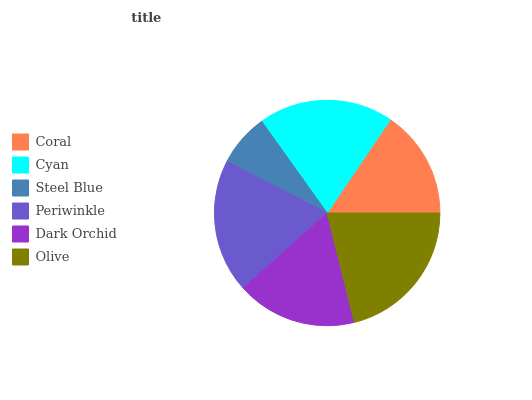Is Steel Blue the minimum?
Answer yes or no. Yes. Is Olive the maximum?
Answer yes or no. Yes. Is Cyan the minimum?
Answer yes or no. No. Is Cyan the maximum?
Answer yes or no. No. Is Cyan greater than Coral?
Answer yes or no. Yes. Is Coral less than Cyan?
Answer yes or no. Yes. Is Coral greater than Cyan?
Answer yes or no. No. Is Cyan less than Coral?
Answer yes or no. No. Is Periwinkle the high median?
Answer yes or no. Yes. Is Dark Orchid the low median?
Answer yes or no. Yes. Is Coral the high median?
Answer yes or no. No. Is Olive the low median?
Answer yes or no. No. 